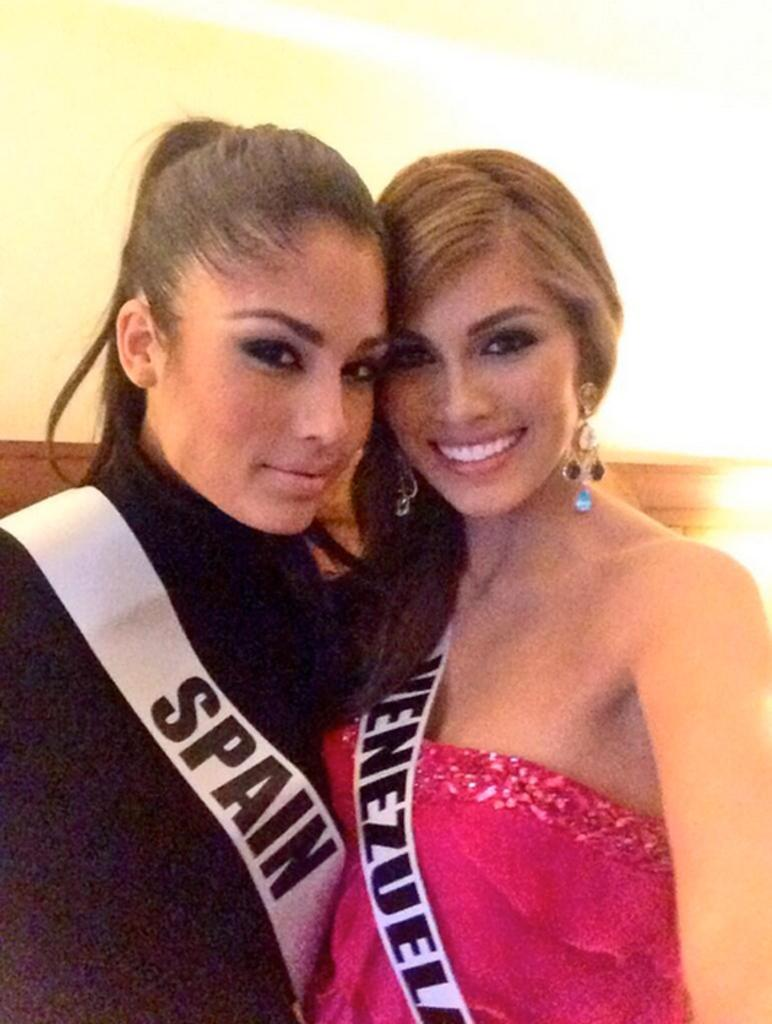<image>
Present a compact description of the photo's key features. Two ladies posing with banner across their chest that has in black letters Spain. 